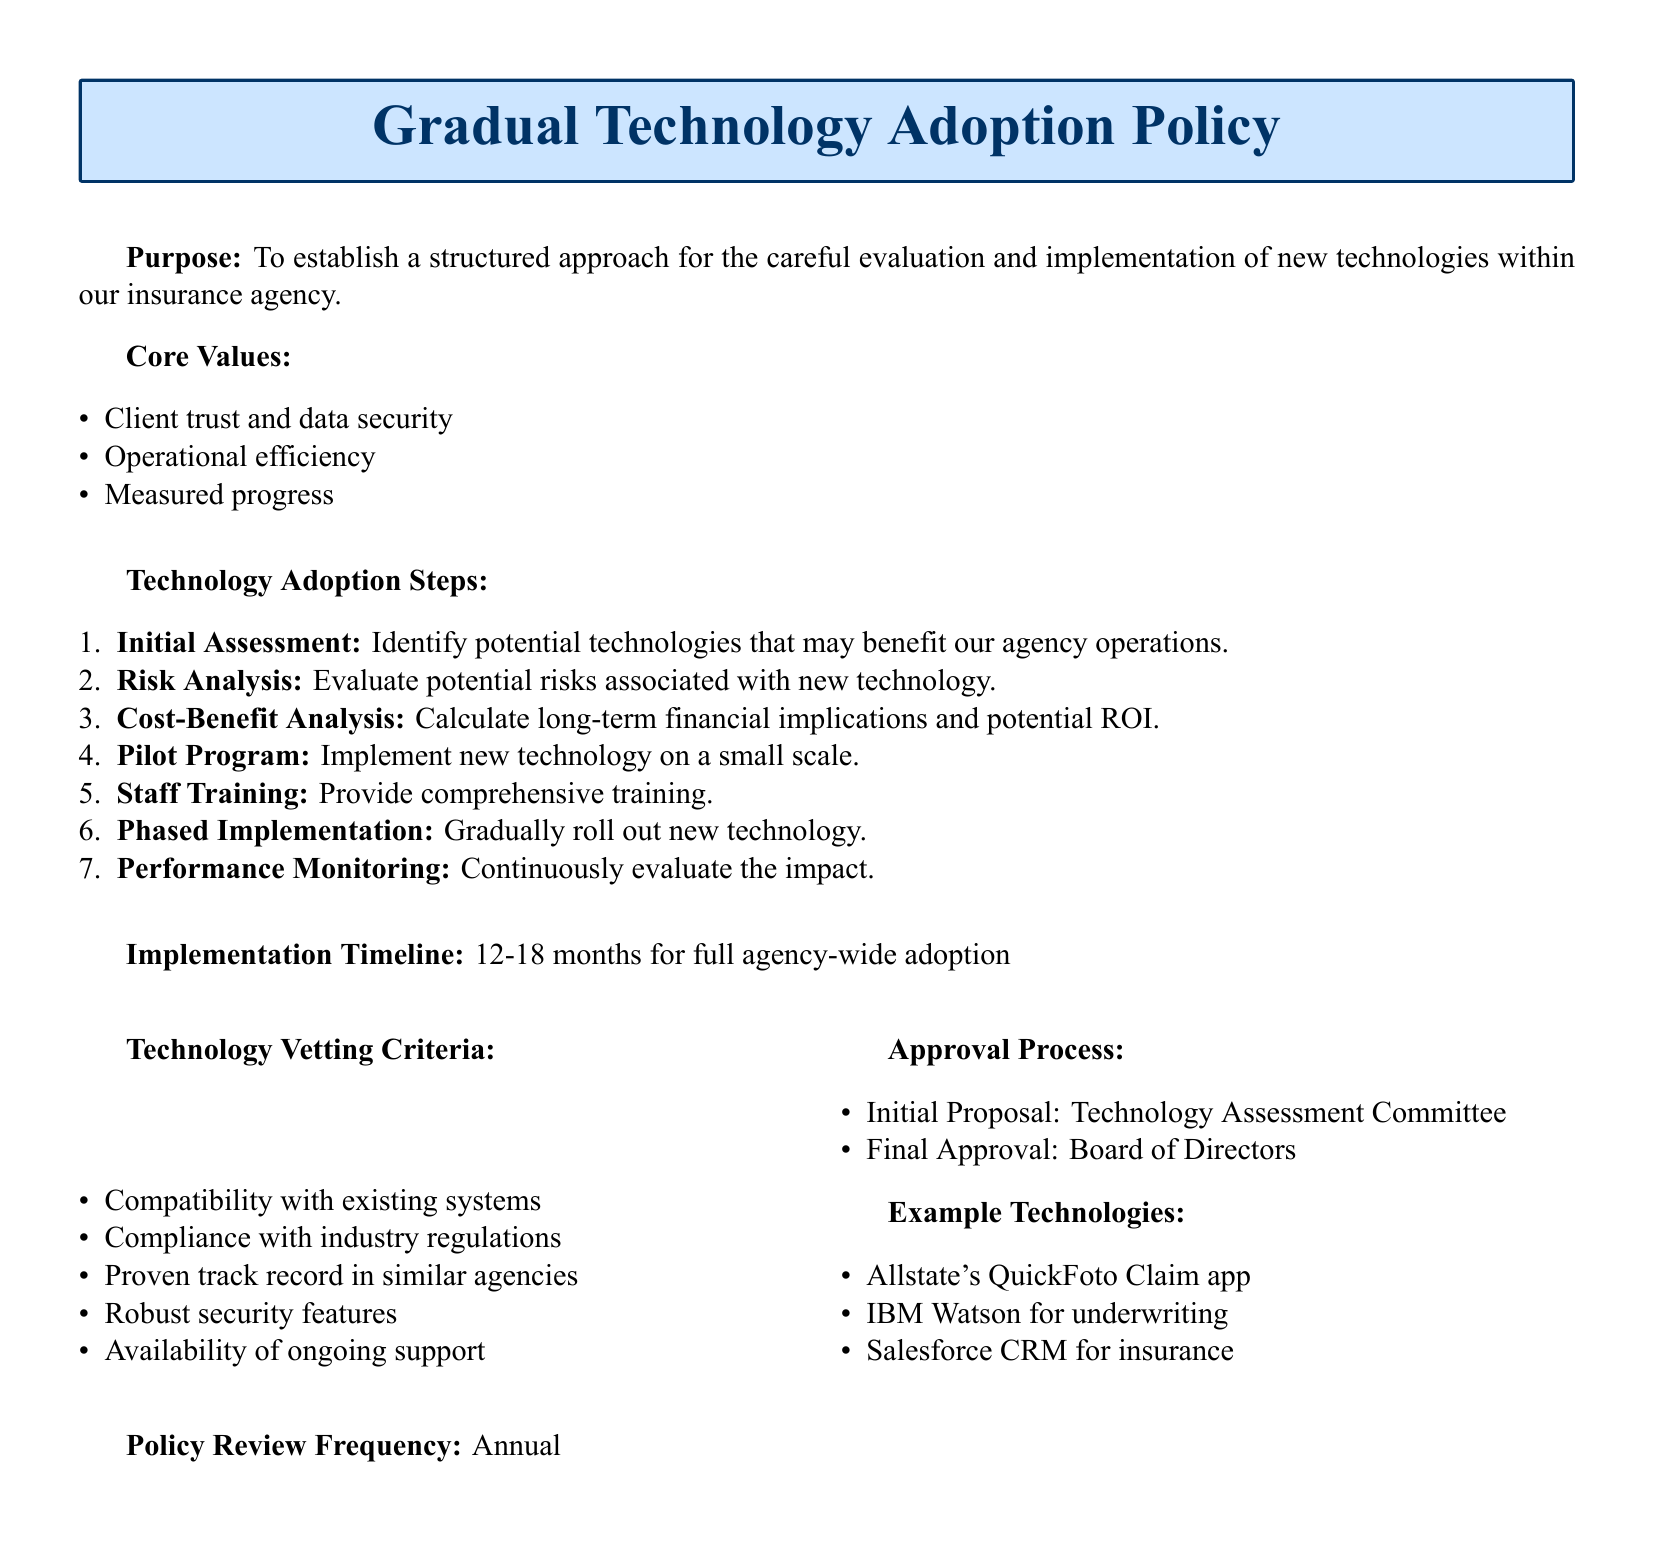What is the purpose of the policy? The purpose is to establish a structured approach for the careful evaluation and implementation of new technologies within our insurance agency.
Answer: To establish a structured approach for the careful evaluation and implementation of new technologies What is the timeframe for full agency-wide adoption? The implementation timeline specifies the duration for adopting the technology agency-wide.
Answer: 12-18 months What is the first step in the technology adoption process? The document outlines the steps for technology adoption, with the first being the initial assessment.
Answer: Initial Assessment What are the core values mentioned in the document? The document lists core values that guide the technology adoption process.
Answer: Client trust and data security, Operational efficiency, Measured progress Who is responsible for the final approval of technology implementation? The approval process identifies who makes the final decision within the organization.
Answer: Board of Directors How often will the policy be reviewed? The document specifies the frequency of policy reviews, ensuring it stays relevant and effective.
Answer: Annual What is included in the technology vetting criteria? This outlines specific aspects to consider when evaluating new technologies before adoption.
Answer: Compatibility with existing systems, Compliance with industry regulations, Proven track record in similar agencies, Robust security features, Availability of ongoing support What is the last step in the technology adoption process? The document describes a monitoring phase to ensure the technology's effective impact is evaluated continuously.
Answer: Performance Monitoring What example technology is mentioned for underwriting? The document provides examples of technologies relevant to insurance processes, particularly for underwriting.
Answer: IBM Watson for underwriting 